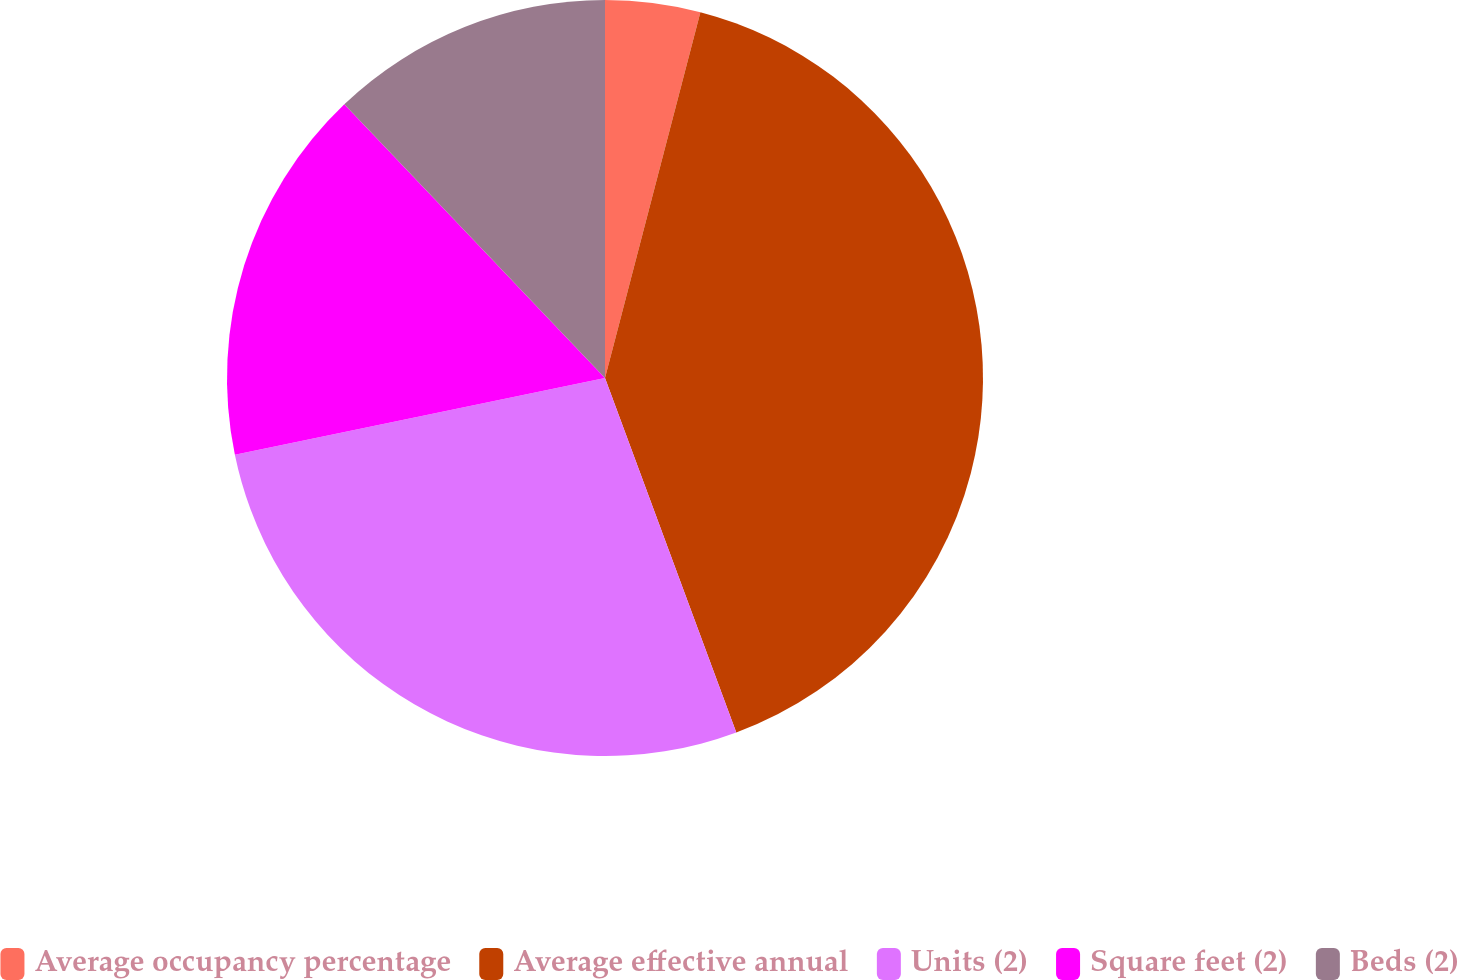<chart> <loc_0><loc_0><loc_500><loc_500><pie_chart><fcel>Average occupancy percentage<fcel>Average effective annual<fcel>Units (2)<fcel>Square feet (2)<fcel>Beds (2)<nl><fcel>4.06%<fcel>40.29%<fcel>27.39%<fcel>16.14%<fcel>12.11%<nl></chart> 